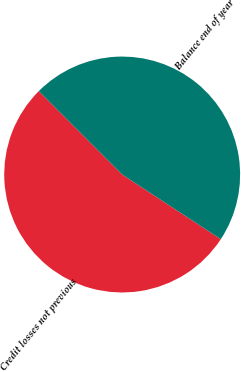Convert chart. <chart><loc_0><loc_0><loc_500><loc_500><pie_chart><fcel>Credit losses not previous<fcel>Balance end of year<nl><fcel>53.26%<fcel>46.74%<nl></chart> 